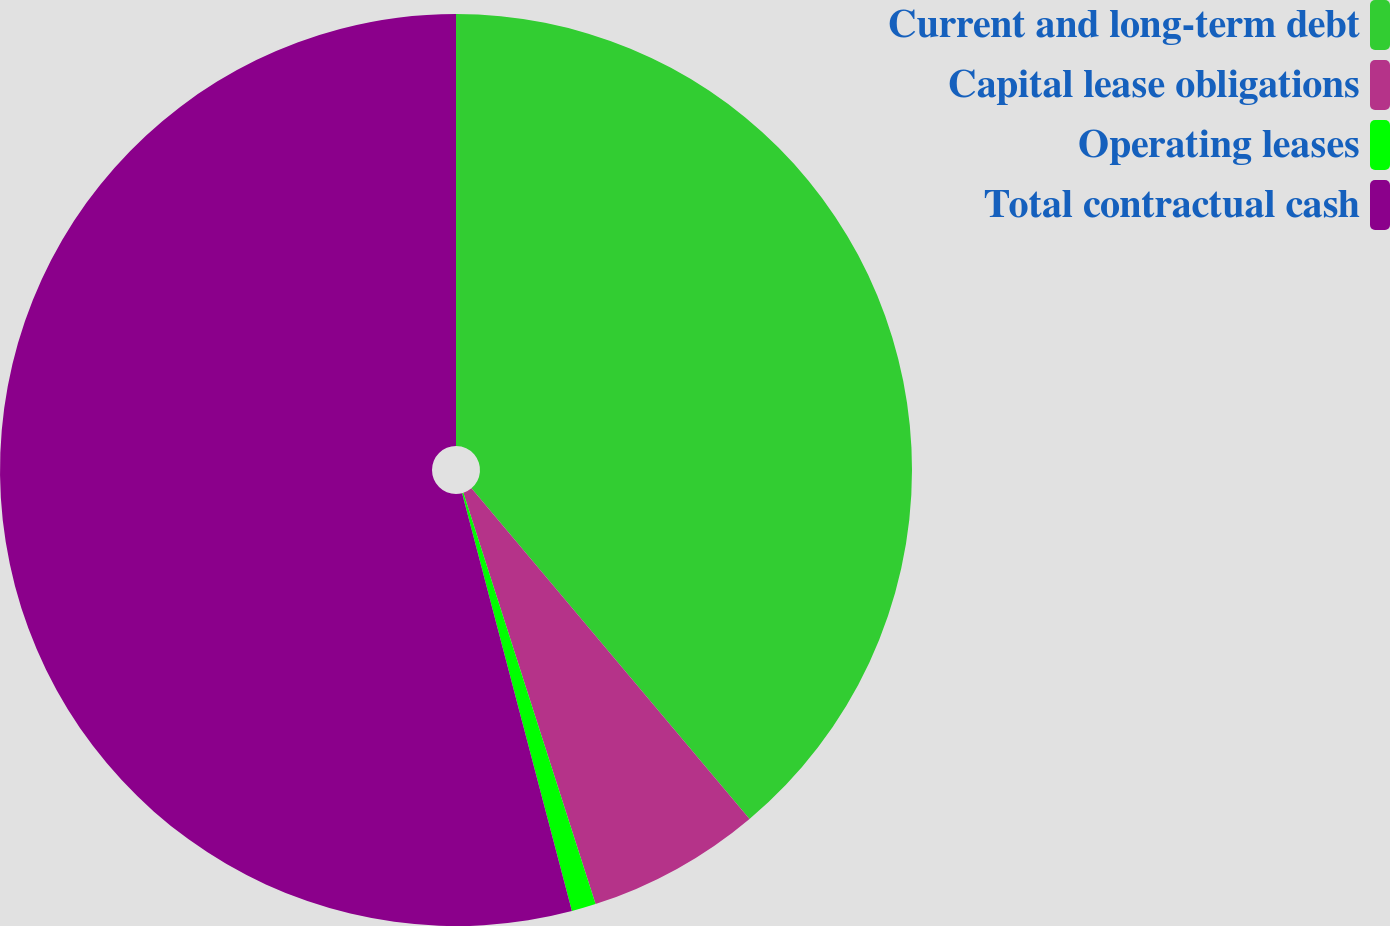Convert chart. <chart><loc_0><loc_0><loc_500><loc_500><pie_chart><fcel>Current and long-term debt<fcel>Capital lease obligations<fcel>Operating leases<fcel>Total contractual cash<nl><fcel>38.87%<fcel>6.18%<fcel>0.86%<fcel>54.09%<nl></chart> 